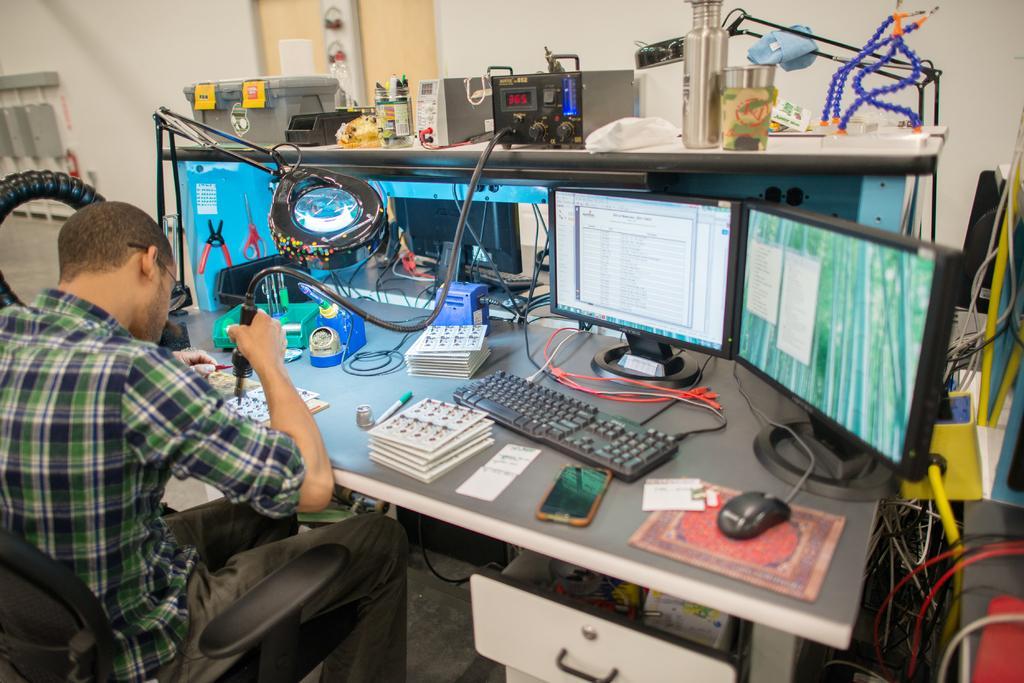How would you summarize this image in a sentence or two? In this image we can see a person sitting on the chair and working with the device in front of a table and on the table we can see monitors, keyboard, mouse, mobile phone, wires and some other objects. In the background we can see measuring meters, glass, a jar with pens, a box and also wires. 